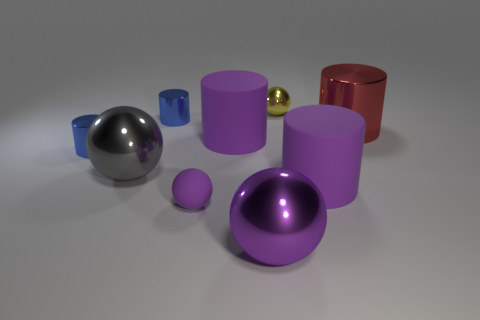Subtract 1 cylinders. How many cylinders are left? 4 Subtract all blue spheres. Subtract all red cubes. How many spheres are left? 4 Add 1 small matte things. How many objects exist? 10 Subtract all cylinders. How many objects are left? 4 Add 8 yellow things. How many yellow things are left? 9 Add 7 blocks. How many blocks exist? 7 Subtract 0 cyan blocks. How many objects are left? 9 Subtract all balls. Subtract all small blue objects. How many objects are left? 3 